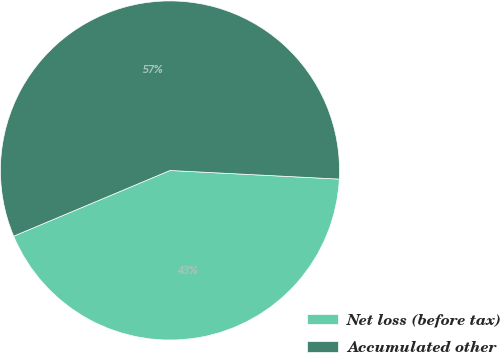Convert chart. <chart><loc_0><loc_0><loc_500><loc_500><pie_chart><fcel>Net loss (before tax)<fcel>Accumulated other<nl><fcel>42.86%<fcel>57.14%<nl></chart> 